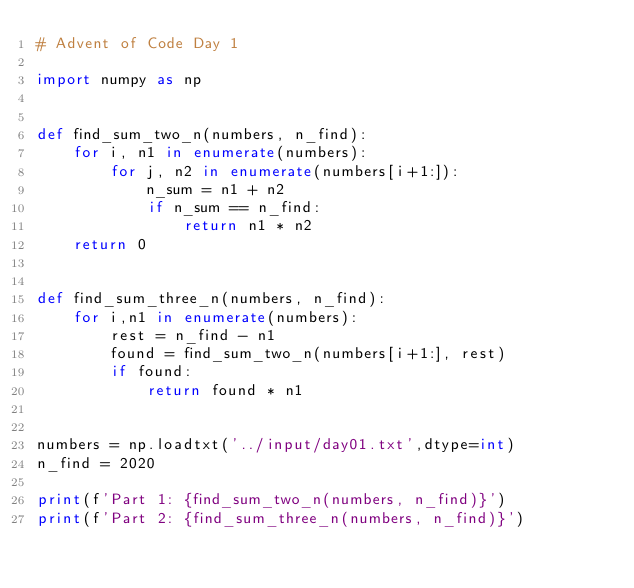Convert code to text. <code><loc_0><loc_0><loc_500><loc_500><_Python_># Advent of Code Day 1

import numpy as np


def find_sum_two_n(numbers, n_find):
    for i, n1 in enumerate(numbers):
        for j, n2 in enumerate(numbers[i+1:]):
            n_sum = n1 + n2
            if n_sum == n_find:
                return n1 * n2
    return 0


def find_sum_three_n(numbers, n_find):
    for i,n1 in enumerate(numbers):
        rest = n_find - n1
        found = find_sum_two_n(numbers[i+1:], rest)
        if found:
            return found * n1


numbers = np.loadtxt('../input/day01.txt',dtype=int)
n_find = 2020

print(f'Part 1: {find_sum_two_n(numbers, n_find)}')
print(f'Part 2: {find_sum_three_n(numbers, n_find)}')

</code> 